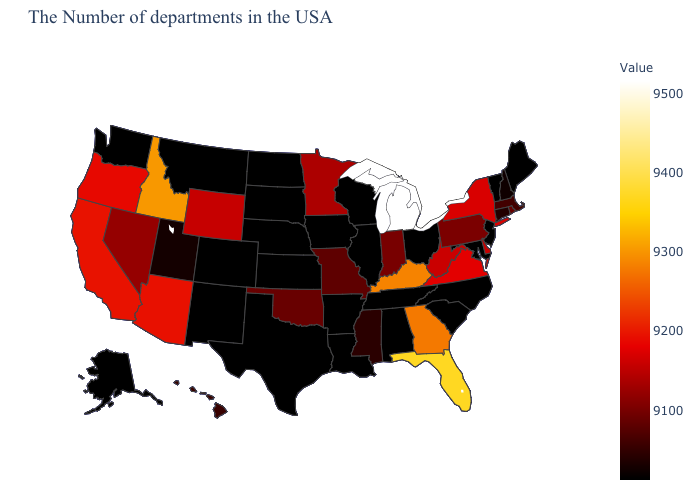Which states hav the highest value in the MidWest?
Write a very short answer. Michigan. Does Michigan have the highest value in the USA?
Give a very brief answer. Yes. Among the states that border New Hampshire , does Maine have the highest value?
Short answer required. No. 